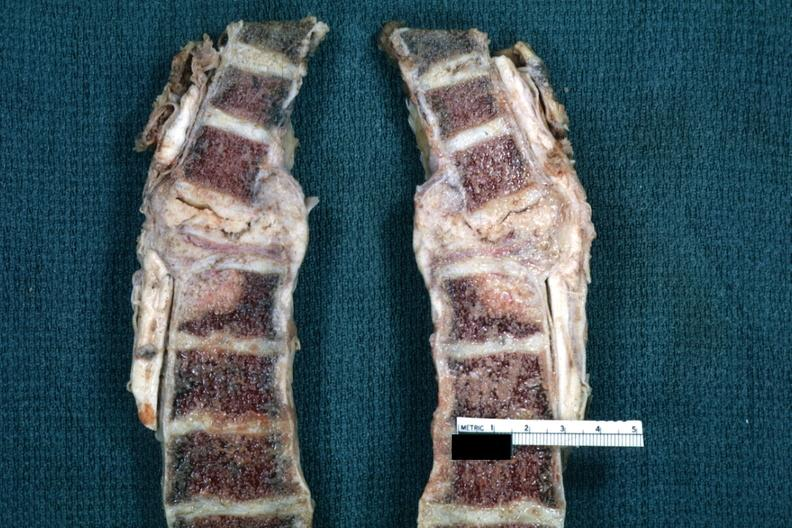s oil wrights cells present?
Answer the question using a single word or phrase. No 